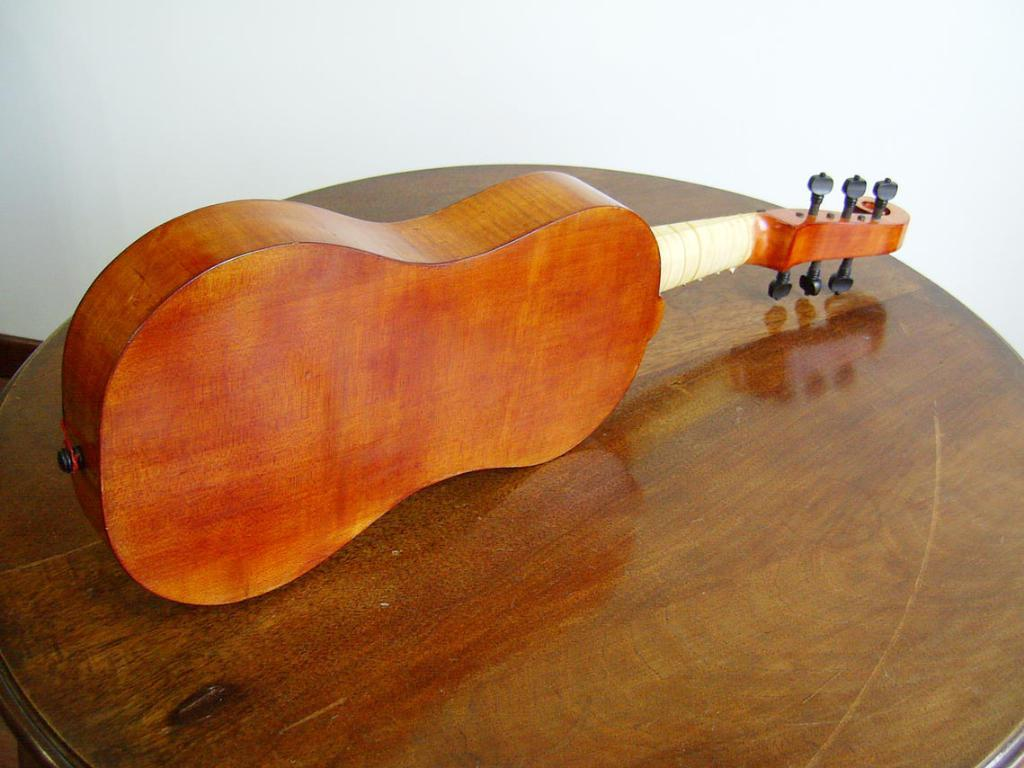What is the main subject of the image? The main subject of the image is the backside of a violin. What can be said about the material of the violin? The violin has a wooden texture. Where is the violin located in the image? The violin is placed on a table. What color is the wall in the background of the image? The wall in the background appears to be white. What type of turkey is depicted on the flag in the image? There is no turkey or flag present in the image; it features the backside of a violin placed on a table with a white wall in the background. 